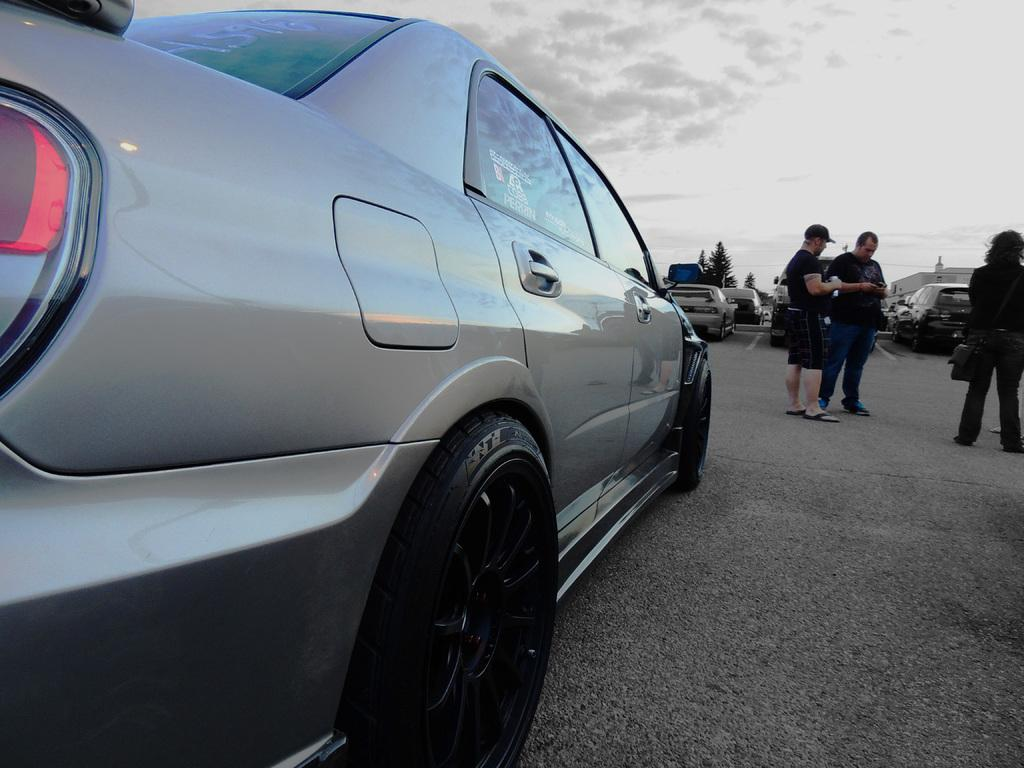What is located on the left side of the image? There is a car on the left side of the image. What can be seen in the background of the image? There are three persons standing, other cars, trees, and the sky visible in the background of the image. Can you describe the sky in the image? The sky is visible at the top of the image, and there is a cloud in the sky. Where is the sofa located in the image? There is no sofa present in the image. What type of coach can be seen in the image? There is no coach present in the image. 